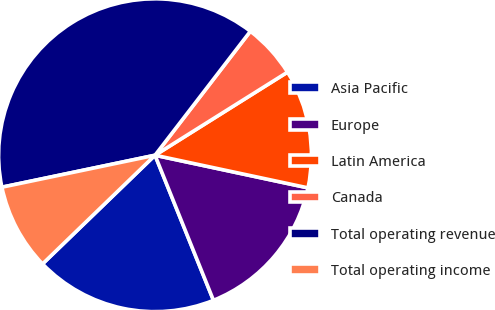Convert chart. <chart><loc_0><loc_0><loc_500><loc_500><pie_chart><fcel>Asia Pacific<fcel>Europe<fcel>Latin America<fcel>Canada<fcel>Total operating revenue<fcel>Total operating income<nl><fcel>18.87%<fcel>15.56%<fcel>12.26%<fcel>5.65%<fcel>38.71%<fcel>8.95%<nl></chart> 